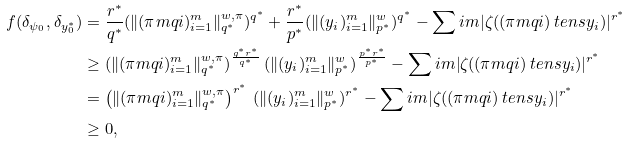<formula> <loc_0><loc_0><loc_500><loc_500>f ( \delta _ { \psi _ { 0 } } , \delta _ { y _ { 0 } ^ { * } } ) & = \frac { r ^ { * } } { q ^ { * } } ( \| ( \pi m q i ) _ { i = 1 } ^ { m } \| _ { q ^ { * } } ^ { w , \pi } ) ^ { q ^ { * } } + \frac { r ^ { * } } { p ^ { * } } ( \| ( y _ { i } ) _ { i = 1 } ^ { m } \| _ { p ^ { * } } ^ { w } ) ^ { q ^ { * } } - \sum i m | \zeta ( ( \pi m q i ) \ t e n s y _ { i } ) | ^ { r ^ { * } } \\ & \geq ( \| ( \pi m q i ) _ { i = 1 } ^ { m } \| _ { q ^ { * } } ^ { w , \pi } ) ^ { \frac { q ^ { * } r ^ { * } } { q ^ { * } } } \, ( \| ( y _ { i } ) _ { i = 1 } ^ { m } \| _ { p ^ { * } } ^ { w } ) ^ { \frac { p ^ { * } r ^ { * } } { p ^ { * } } } - \sum i m | \zeta ( ( \pi m q i ) \ t e n s y _ { i } ) | ^ { r ^ { * } } \\ & = \left ( \| ( \pi m q i ) _ { i = 1 } ^ { m } \| _ { q ^ { * } } ^ { w , \pi } \right ) ^ { r ^ { * } } \, ( \| ( y _ { i } ) _ { i = 1 } ^ { m } \| _ { p ^ { * } } ^ { w } ) ^ { r ^ { * } } - \sum i m | \zeta ( ( \pi m q i ) \ t e n s y _ { i } ) | ^ { r ^ { * } } \\ & \geq 0 ,</formula> 